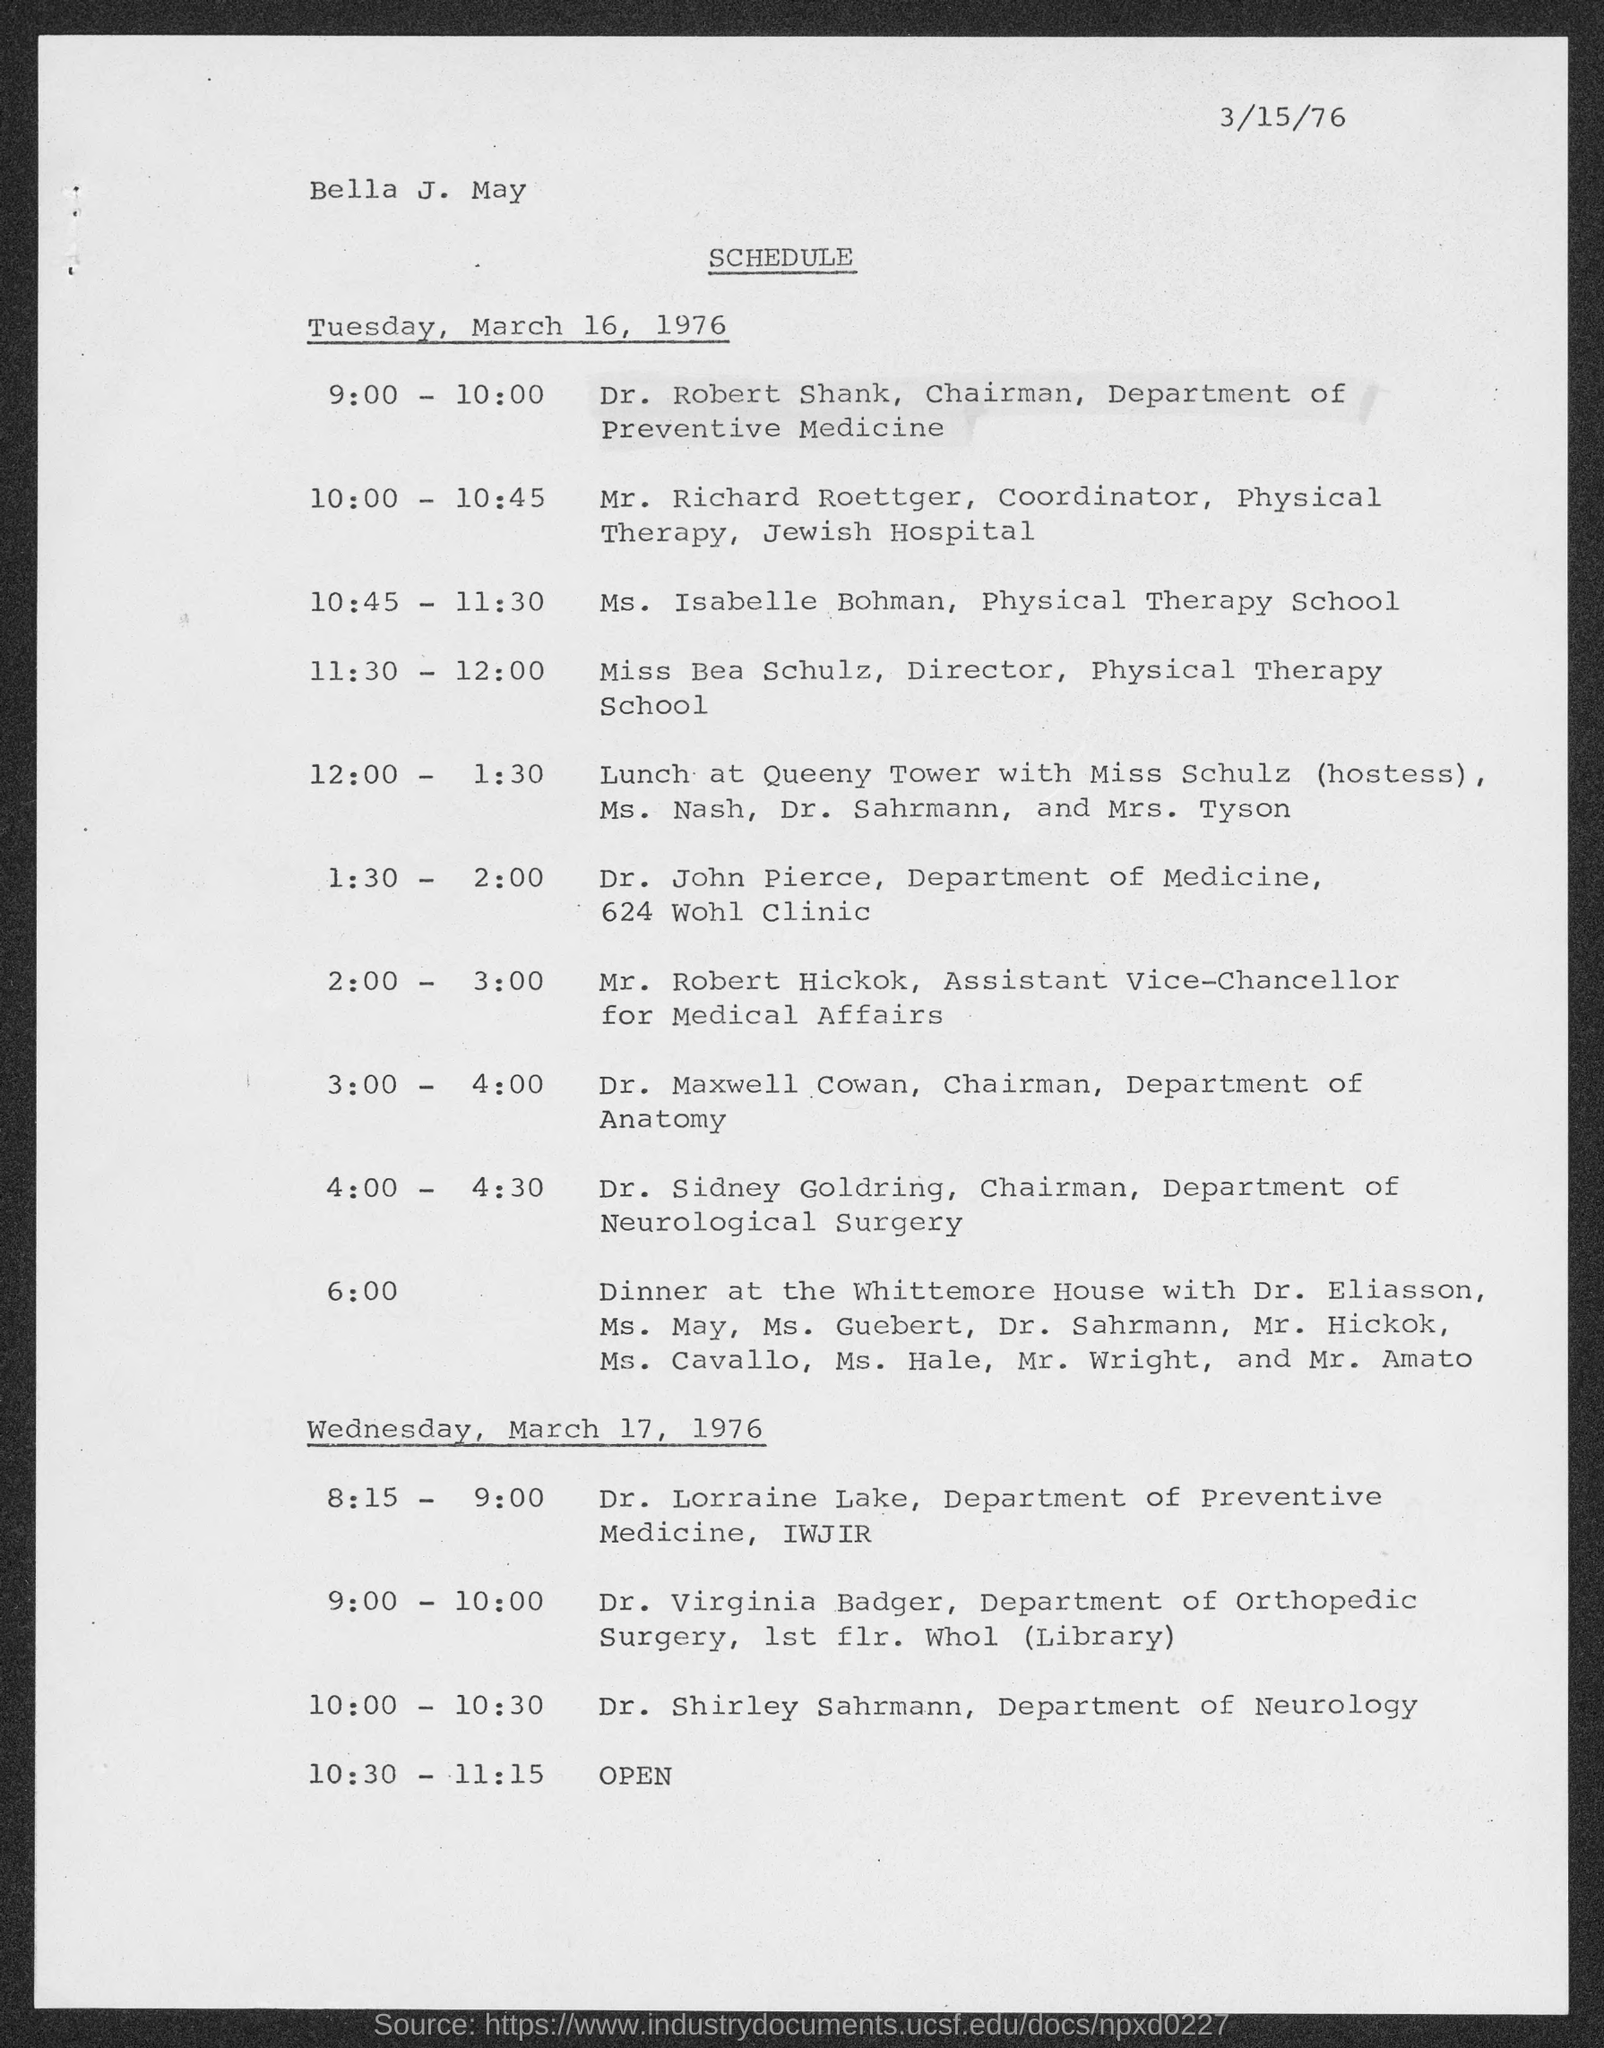Indicate a few pertinent items in this graphic. Dr. Maxwell Cowan holds the position of Chairman in the Department of Anatomy. Mr. Richard Roettger is the Coordinator of Physical Therapy at Jewish Hospital. Dr. Sidney Goldring holds the position of Chairman of the Department of Neurological Surgery. Miss Bea Schulz is the Director of the Physical Therapy School. Dr. Robert Shank holds the position of Chairman of the Department of Preventive Medicine. 